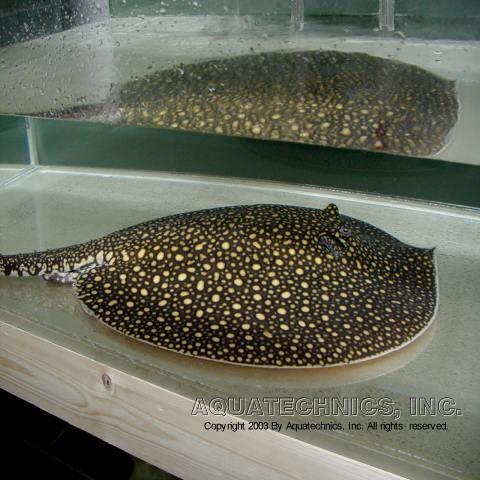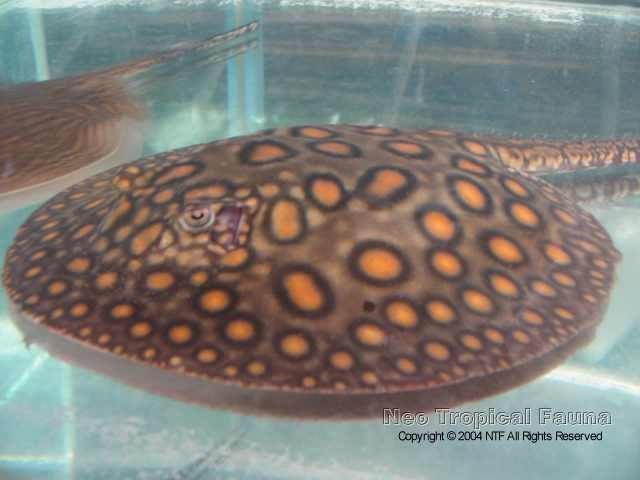The first image is the image on the left, the second image is the image on the right. For the images displayed, is the sentence "An image shows one dark stingray with small pale dots." factually correct? Answer yes or no. Yes. 